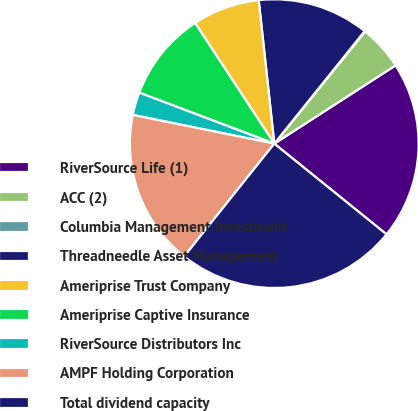Convert chart. <chart><loc_0><loc_0><loc_500><loc_500><pie_chart><fcel>RiverSource Life (1)<fcel>ACC (2)<fcel>Columbia Management Investment<fcel>Threadneedle Asset Management<fcel>Ameriprise Trust Company<fcel>Ameriprise Captive Insurance<fcel>RiverSource Distributors Inc<fcel>AMPF Holding Corporation<fcel>Total dividend capacity<nl><fcel>19.94%<fcel>5.04%<fcel>0.07%<fcel>12.49%<fcel>7.52%<fcel>10.01%<fcel>2.56%<fcel>17.46%<fcel>24.91%<nl></chart> 